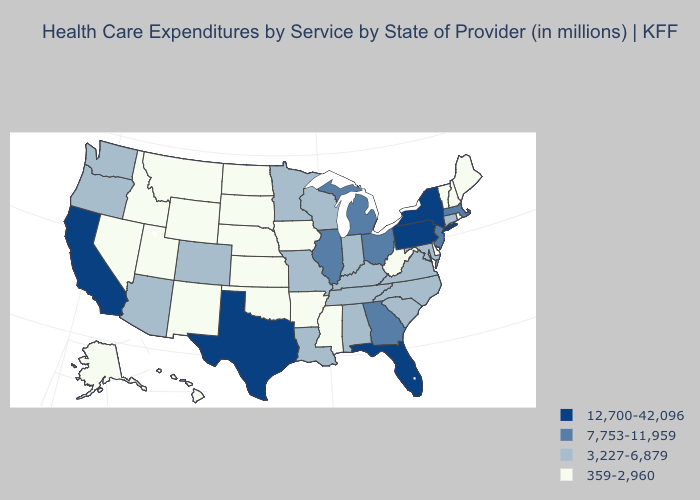Among the states that border California , which have the highest value?
Concise answer only. Arizona, Oregon. Name the states that have a value in the range 359-2,960?
Give a very brief answer. Alaska, Arkansas, Delaware, Hawaii, Idaho, Iowa, Kansas, Maine, Mississippi, Montana, Nebraska, Nevada, New Hampshire, New Mexico, North Dakota, Oklahoma, Rhode Island, South Dakota, Utah, Vermont, West Virginia, Wyoming. What is the highest value in the South ?
Keep it brief. 12,700-42,096. Does South Carolina have the highest value in the USA?
Be succinct. No. What is the value of New Mexico?
Give a very brief answer. 359-2,960. Among the states that border Delaware , which have the highest value?
Keep it brief. Pennsylvania. What is the value of Wyoming?
Give a very brief answer. 359-2,960. What is the highest value in the Northeast ?
Concise answer only. 12,700-42,096. What is the value of Indiana?
Write a very short answer. 3,227-6,879. Name the states that have a value in the range 3,227-6,879?
Write a very short answer. Alabama, Arizona, Colorado, Connecticut, Indiana, Kentucky, Louisiana, Maryland, Minnesota, Missouri, North Carolina, Oregon, South Carolina, Tennessee, Virginia, Washington, Wisconsin. Does Washington have the lowest value in the USA?
Concise answer only. No. What is the lowest value in the USA?
Be succinct. 359-2,960. Among the states that border Alabama , which have the lowest value?
Be succinct. Mississippi. What is the highest value in the USA?
Give a very brief answer. 12,700-42,096. Does the first symbol in the legend represent the smallest category?
Short answer required. No. 